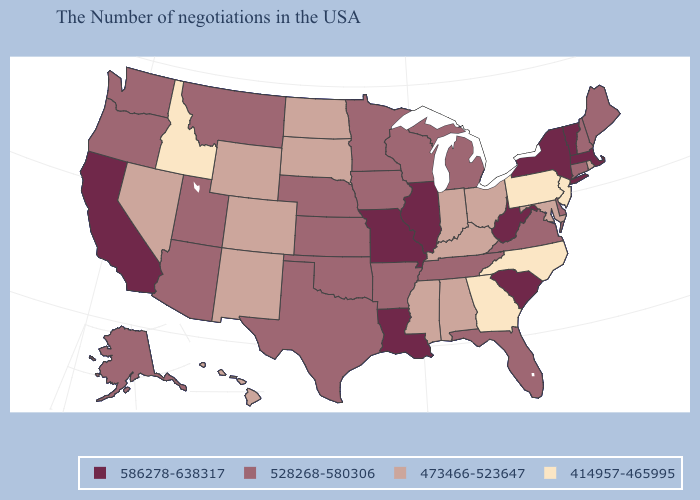What is the value of Arizona?
Concise answer only. 528268-580306. Is the legend a continuous bar?
Write a very short answer. No. What is the lowest value in states that border North Dakota?
Write a very short answer. 473466-523647. Does Nebraska have a lower value than New York?
Give a very brief answer. Yes. Which states have the lowest value in the MidWest?
Quick response, please. Ohio, Indiana, South Dakota, North Dakota. What is the value of Georgia?
Give a very brief answer. 414957-465995. Name the states that have a value in the range 528268-580306?
Concise answer only. Maine, New Hampshire, Connecticut, Delaware, Virginia, Florida, Michigan, Tennessee, Wisconsin, Arkansas, Minnesota, Iowa, Kansas, Nebraska, Oklahoma, Texas, Utah, Montana, Arizona, Washington, Oregon, Alaska. What is the lowest value in the Northeast?
Answer briefly. 414957-465995. What is the value of South Carolina?
Quick response, please. 586278-638317. What is the value of Indiana?
Write a very short answer. 473466-523647. Does North Carolina have the same value as Pennsylvania?
Keep it brief. Yes. Does Pennsylvania have a lower value than Idaho?
Quick response, please. No. What is the value of Kansas?
Short answer required. 528268-580306. Name the states that have a value in the range 473466-523647?
Give a very brief answer. Rhode Island, Maryland, Ohio, Kentucky, Indiana, Alabama, Mississippi, South Dakota, North Dakota, Wyoming, Colorado, New Mexico, Nevada, Hawaii. Name the states that have a value in the range 586278-638317?
Write a very short answer. Massachusetts, Vermont, New York, South Carolina, West Virginia, Illinois, Louisiana, Missouri, California. 